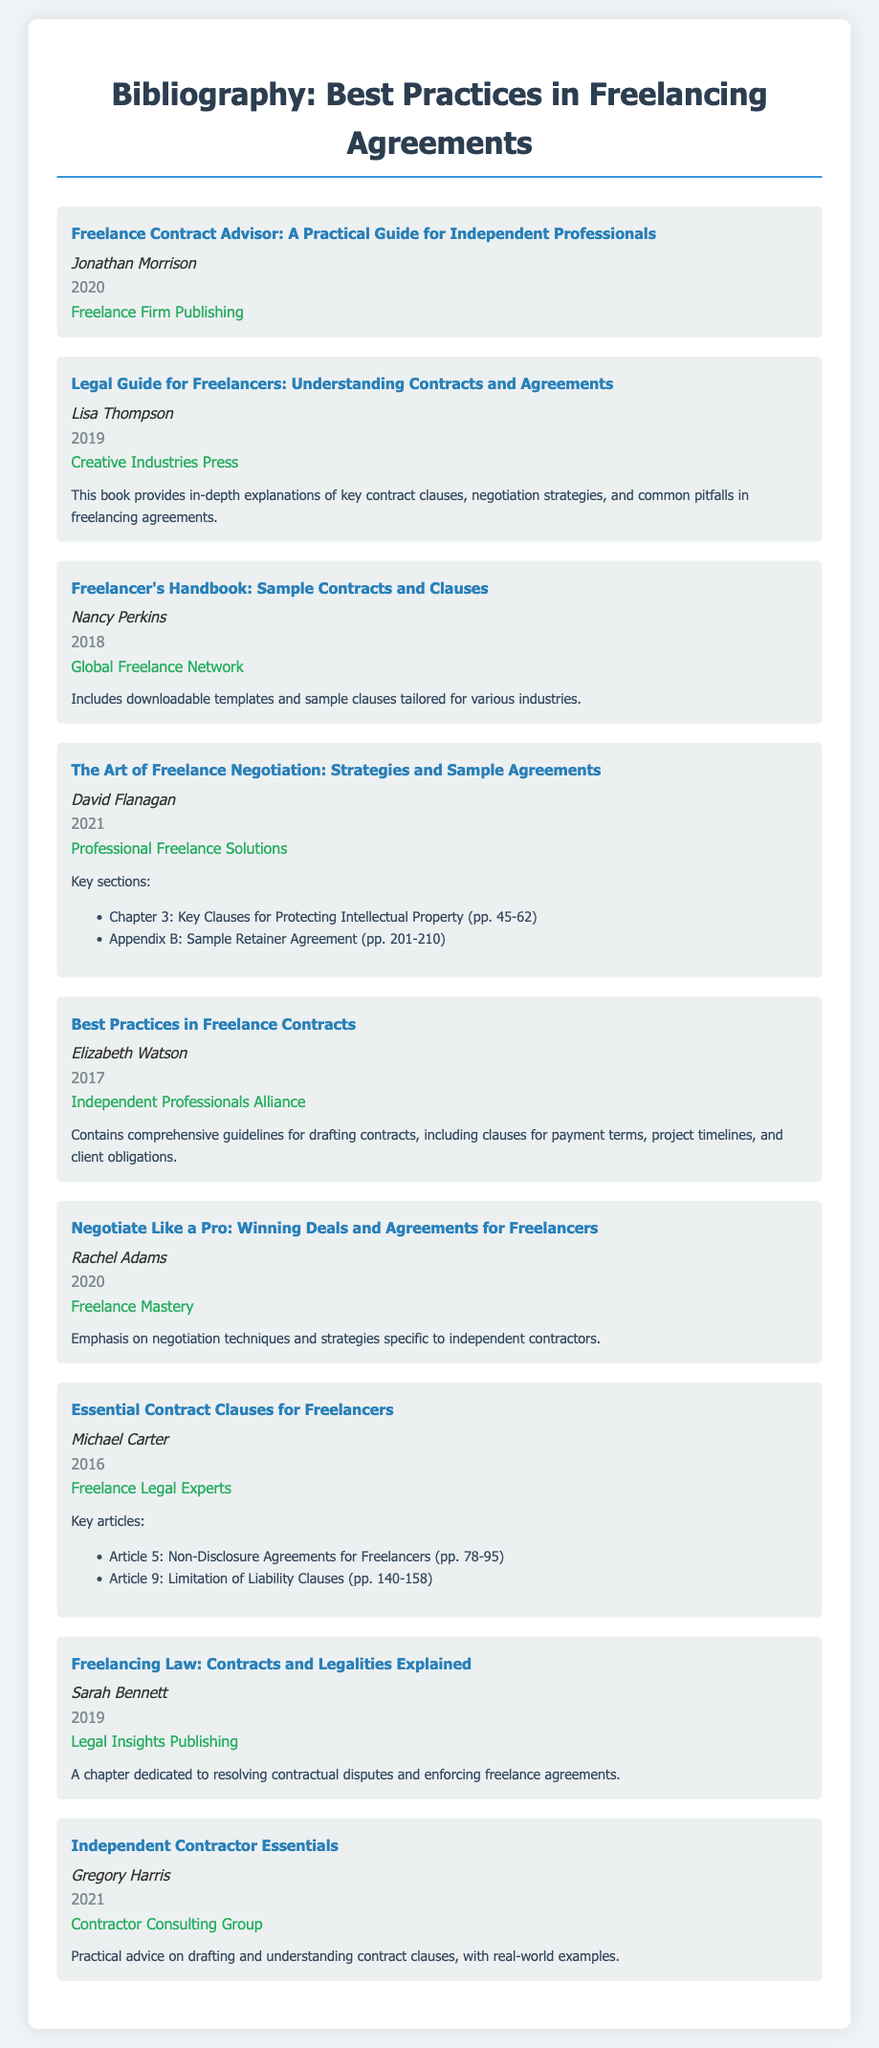what is the title of the first item in the bibliography? The title of the first item is presented in the document as "Freelance Contract Advisor: A Practical Guide for Independent Professionals."
Answer: Freelance Contract Advisor: A Practical Guide for Independent Professionals who is the author of the book published in 2019? The document specifies that the book published in 2019 is authored by Lisa Thompson.
Answer: Lisa Thompson how many items are listed in this bibliography? The document contains a total of eight distinct items listed under the bibliography section.
Answer: 8 what year was "Essential Contract Clauses for Freelancers" published? The publication year for "Essential Contract Clauses for Freelancers" is clearly mentioned in the document as 2016.
Answer: 2016 which item includes downloadable templates? The item that includes downloadable templates is "Freelancer's Handbook: Sample Contracts and Clauses."
Answer: Freelancer's Handbook: Sample Contracts and Clauses who is the author of "Negotiate Like a Pro: Winning Deals and Agreements for Freelancers"? The author's name for this book is Rachel Adams, as indicated in the document.
Answer: Rachel Adams what is a key focus area mentioned for the book authored by David Flanagan? The document states that a key focus area for the book authored by David Flanagan is "Strategies and Sample Agreements."
Answer: Strategies and Sample Agreements which publisher released the book titled "Freelancing Law: Contracts and Legalities Explained"? The publisher for this book is Legal Insights Publishing, as detailed in the bibliography.
Answer: Legal Insights Publishing 